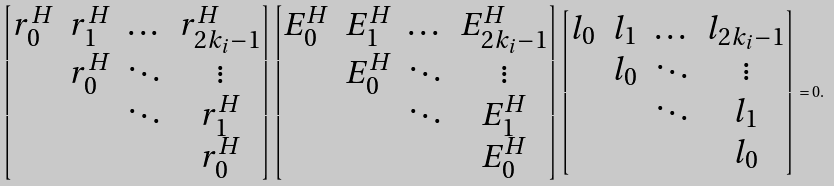Convert formula to latex. <formula><loc_0><loc_0><loc_500><loc_500>\begin{bmatrix} r _ { 0 } ^ { H } & r _ { 1 } ^ { H } & \dots & r _ { 2 k _ { i } - 1 } ^ { H } \\ & r _ { 0 } ^ { H } & \ddots & \vdots \\ & & \ddots & r _ { 1 } ^ { H } \\ & & & r _ { 0 } ^ { H } \end{bmatrix} \begin{bmatrix} E _ { 0 } ^ { H } & E _ { 1 } ^ { H } & \dots & E _ { 2 k _ { i } - 1 } ^ { H } \\ & E _ { 0 } ^ { H } & \ddots & \vdots \\ & & \ddots & E _ { 1 } ^ { H } \\ & & & E _ { 0 } ^ { H } \end{bmatrix} \begin{bmatrix} l _ { 0 } & l _ { 1 } & \dots & l _ { 2 k _ { i } - 1 } \\ & l _ { 0 } & \ddots & \vdots \\ & & \ddots & l _ { 1 } \\ & & & l _ { 0 } \end{bmatrix} = 0 .</formula> 